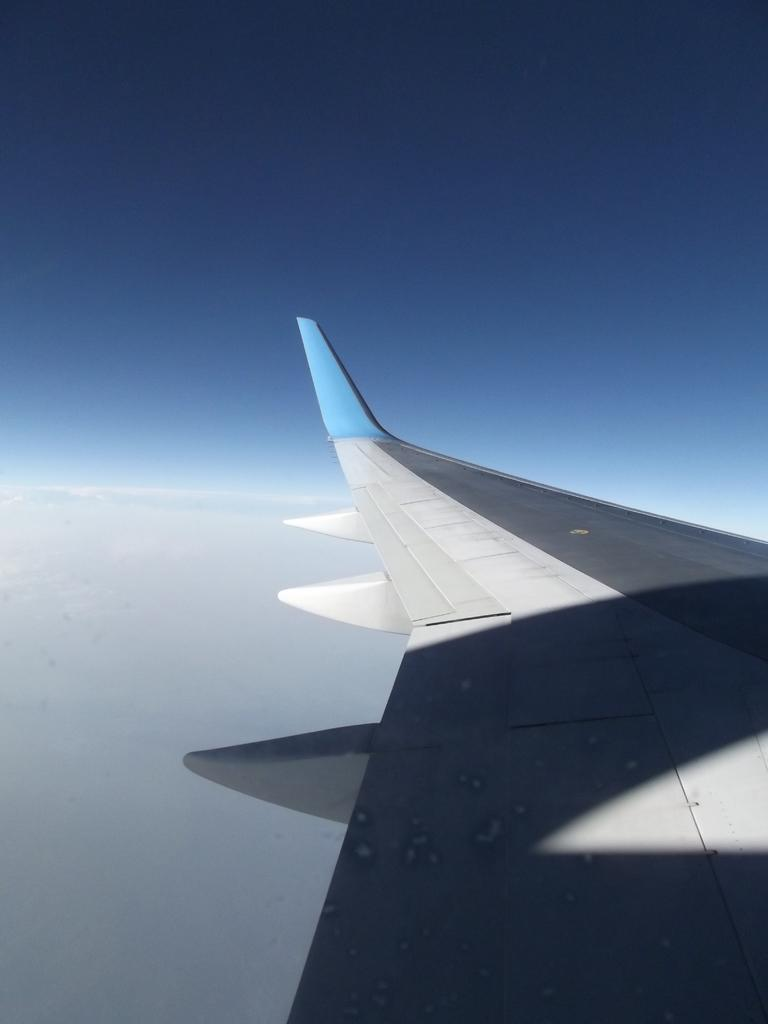What is the main subject of the image? The main subject of the image is a wing of an airplane. What can be seen in the background of the image? The sky is visible in the background of the image. Are there any additional features in the background? Yes, clouds are present in the background of the image. How many elbows can be seen in the image? There are no elbows present in the image. What is the airplane pushing in the image? The image does not depict an airplane pushing anything; it only shows a wing. 